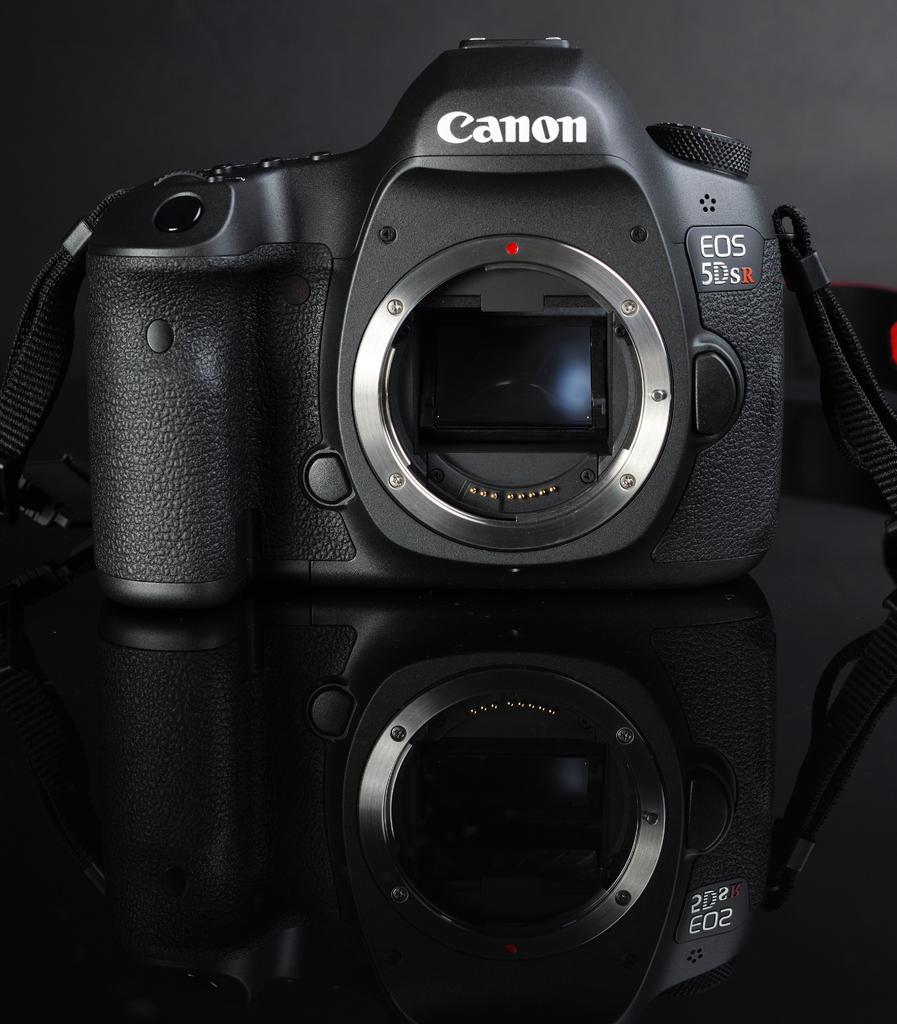Provide a one-sentence caption for the provided image. A Black Canon Eos 5Dsr Camera sitting on a black glass table. 